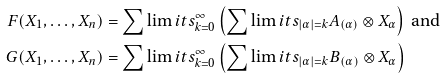<formula> <loc_0><loc_0><loc_500><loc_500>F ( X _ { 1 } , \dots , X _ { n } ) & = \sum \lim i t s _ { k = 0 } ^ { \infty } \left ( \sum \lim i t s _ { | \alpha | = k } A _ { ( \alpha ) } \otimes X _ { \alpha } \right ) \text { and } \\ G ( X _ { 1 } , \dots , X _ { n } ) & = \sum \lim i t s _ { k = 0 } ^ { \infty } \left ( \sum \lim i t s _ { | \alpha | = k } B _ { ( \alpha ) } \otimes X _ { \alpha } \right )</formula> 